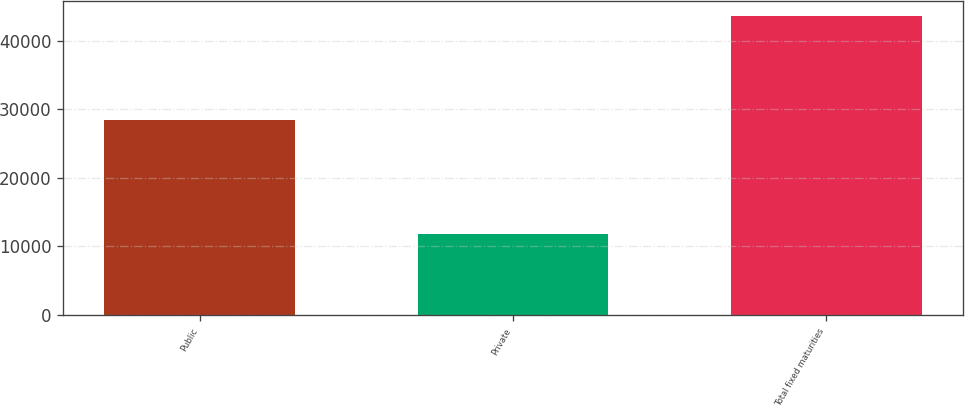Convert chart. <chart><loc_0><loc_0><loc_500><loc_500><bar_chart><fcel>Public<fcel>Private<fcel>Total fixed maturities<nl><fcel>28415.7<fcel>11839.8<fcel>43653<nl></chart> 